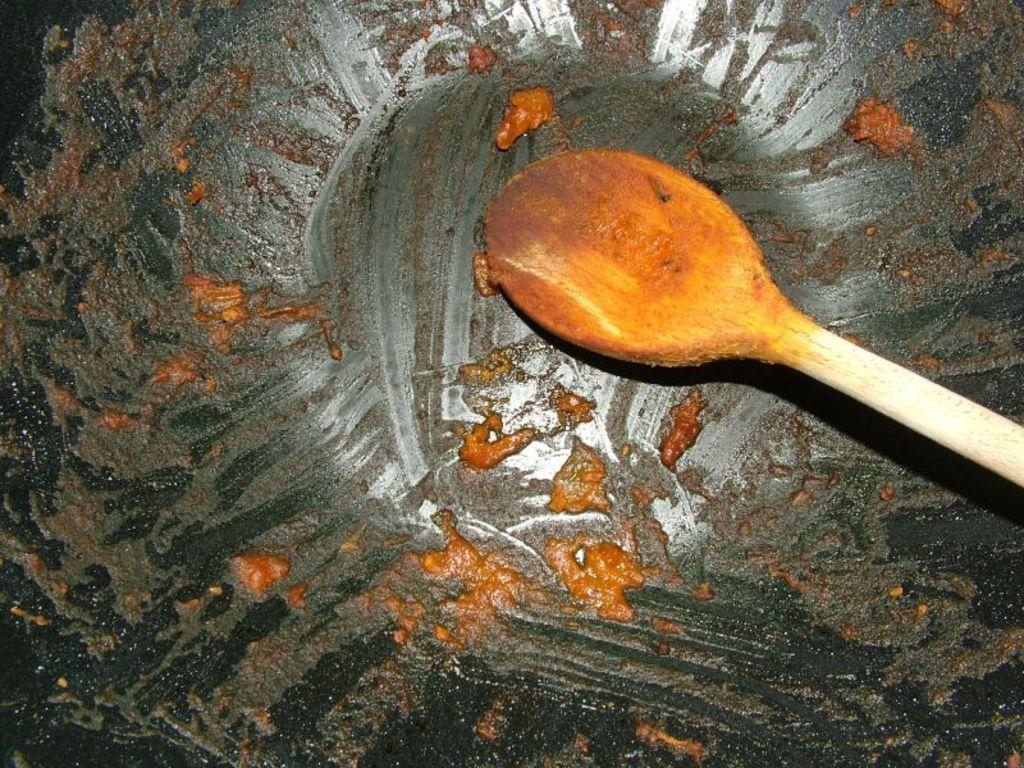What is present in the image that can be used for serving food? There is a wooden serving spoon in the image. What type of container is visible in the image? There is a bowl in the image. How many stitches are visible on the wooden serving spoon in the image? There are no stitches visible on the wooden serving spoon in the image, as it is a solid piece of wood. 